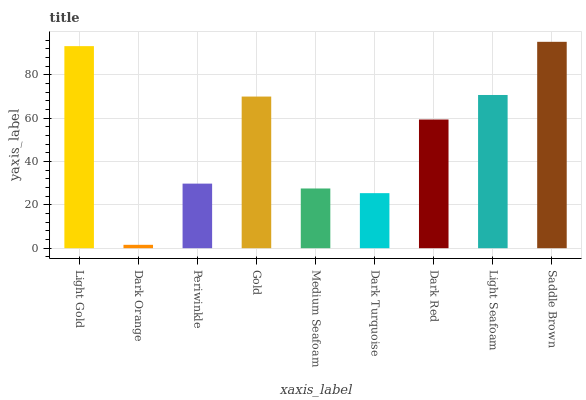Is Dark Orange the minimum?
Answer yes or no. Yes. Is Saddle Brown the maximum?
Answer yes or no. Yes. Is Periwinkle the minimum?
Answer yes or no. No. Is Periwinkle the maximum?
Answer yes or no. No. Is Periwinkle greater than Dark Orange?
Answer yes or no. Yes. Is Dark Orange less than Periwinkle?
Answer yes or no. Yes. Is Dark Orange greater than Periwinkle?
Answer yes or no. No. Is Periwinkle less than Dark Orange?
Answer yes or no. No. Is Dark Red the high median?
Answer yes or no. Yes. Is Dark Red the low median?
Answer yes or no. Yes. Is Dark Orange the high median?
Answer yes or no. No. Is Medium Seafoam the low median?
Answer yes or no. No. 